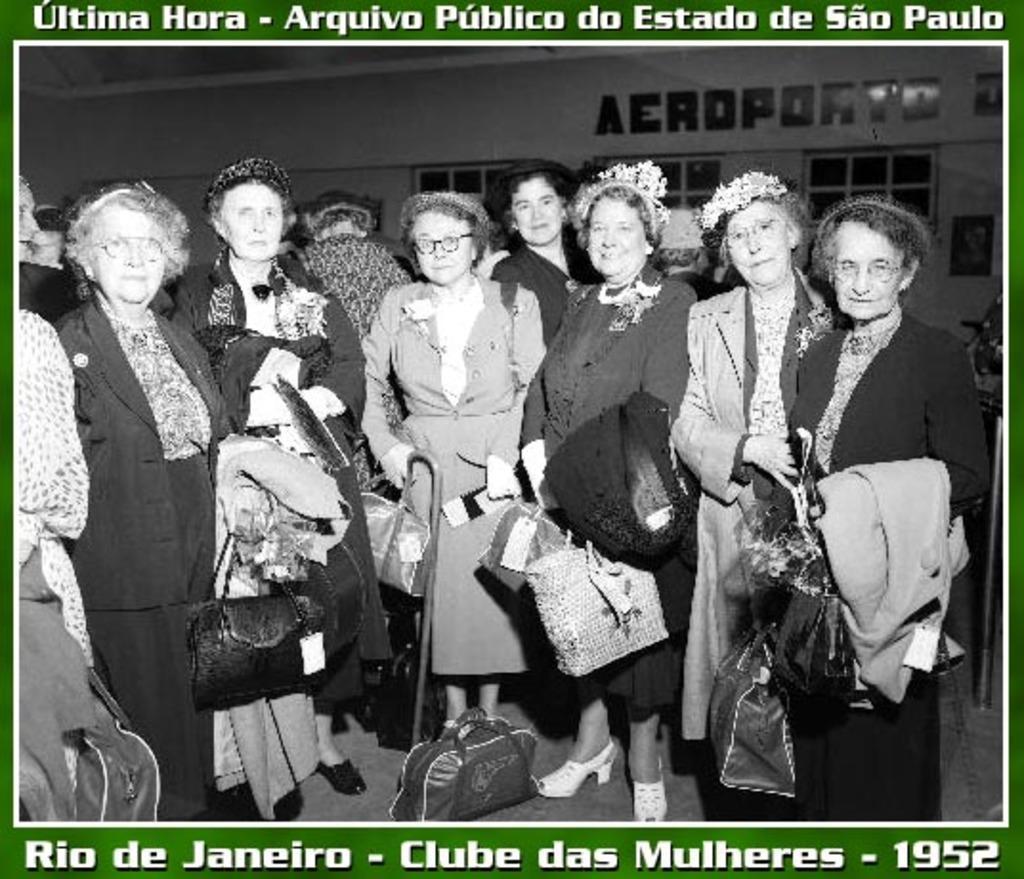Could you give a brief overview of what you see in this image? This is a poster. In this image there are group of people standing and holding the bags. At the back there is a text on the wall and there are windows and there are frames on the wall. On the right side of the image there is an object. At the top and at the bottom of the image there is a text. 